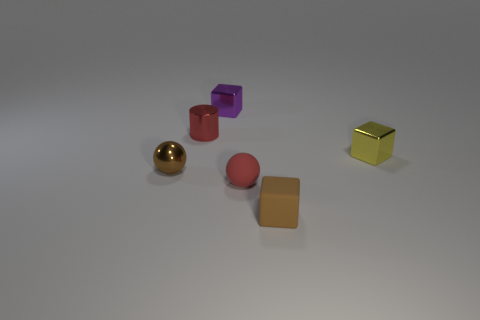Add 3 small metallic balls. How many objects exist? 9 Subtract 1 cubes. How many cubes are left? 2 Subtract all balls. How many objects are left? 4 Subtract all small brown shiny cylinders. Subtract all tiny brown rubber things. How many objects are left? 5 Add 1 balls. How many balls are left? 3 Add 6 small red spheres. How many small red spheres exist? 7 Subtract 0 cyan cylinders. How many objects are left? 6 